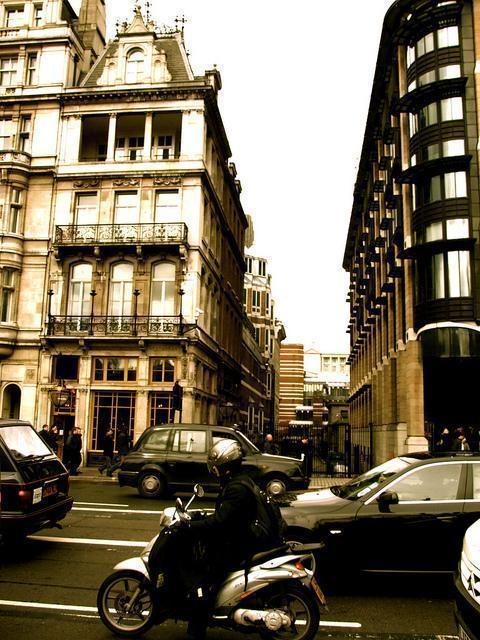How many motorcycles do you see?
Choose the correct response, then elucidate: 'Answer: answer
Rationale: rationale.'
Options: Four, three, six, one. Answer: one.
Rationale: There is only one two wheeled motor vehicle present in this city traffic scene. 